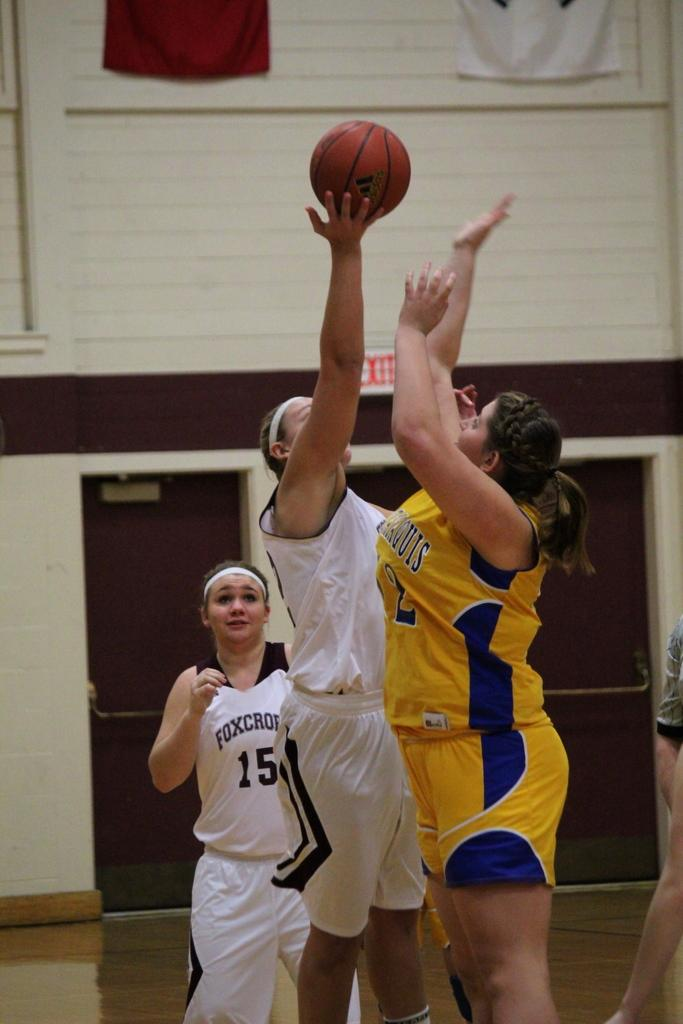<image>
Summarize the visual content of the image. a person that has the number 15 on their outfit 